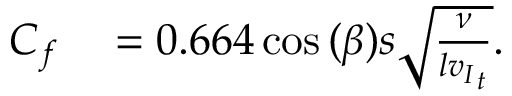Convert formula to latex. <formula><loc_0><loc_0><loc_500><loc_500>\begin{array} { r l } { C _ { f } } & 0 . 6 6 4 \cos { ( \beta ) } s \sqrt { \frac { \nu } { l { v _ { I } } _ { t } } } . } \end{array}</formula> 